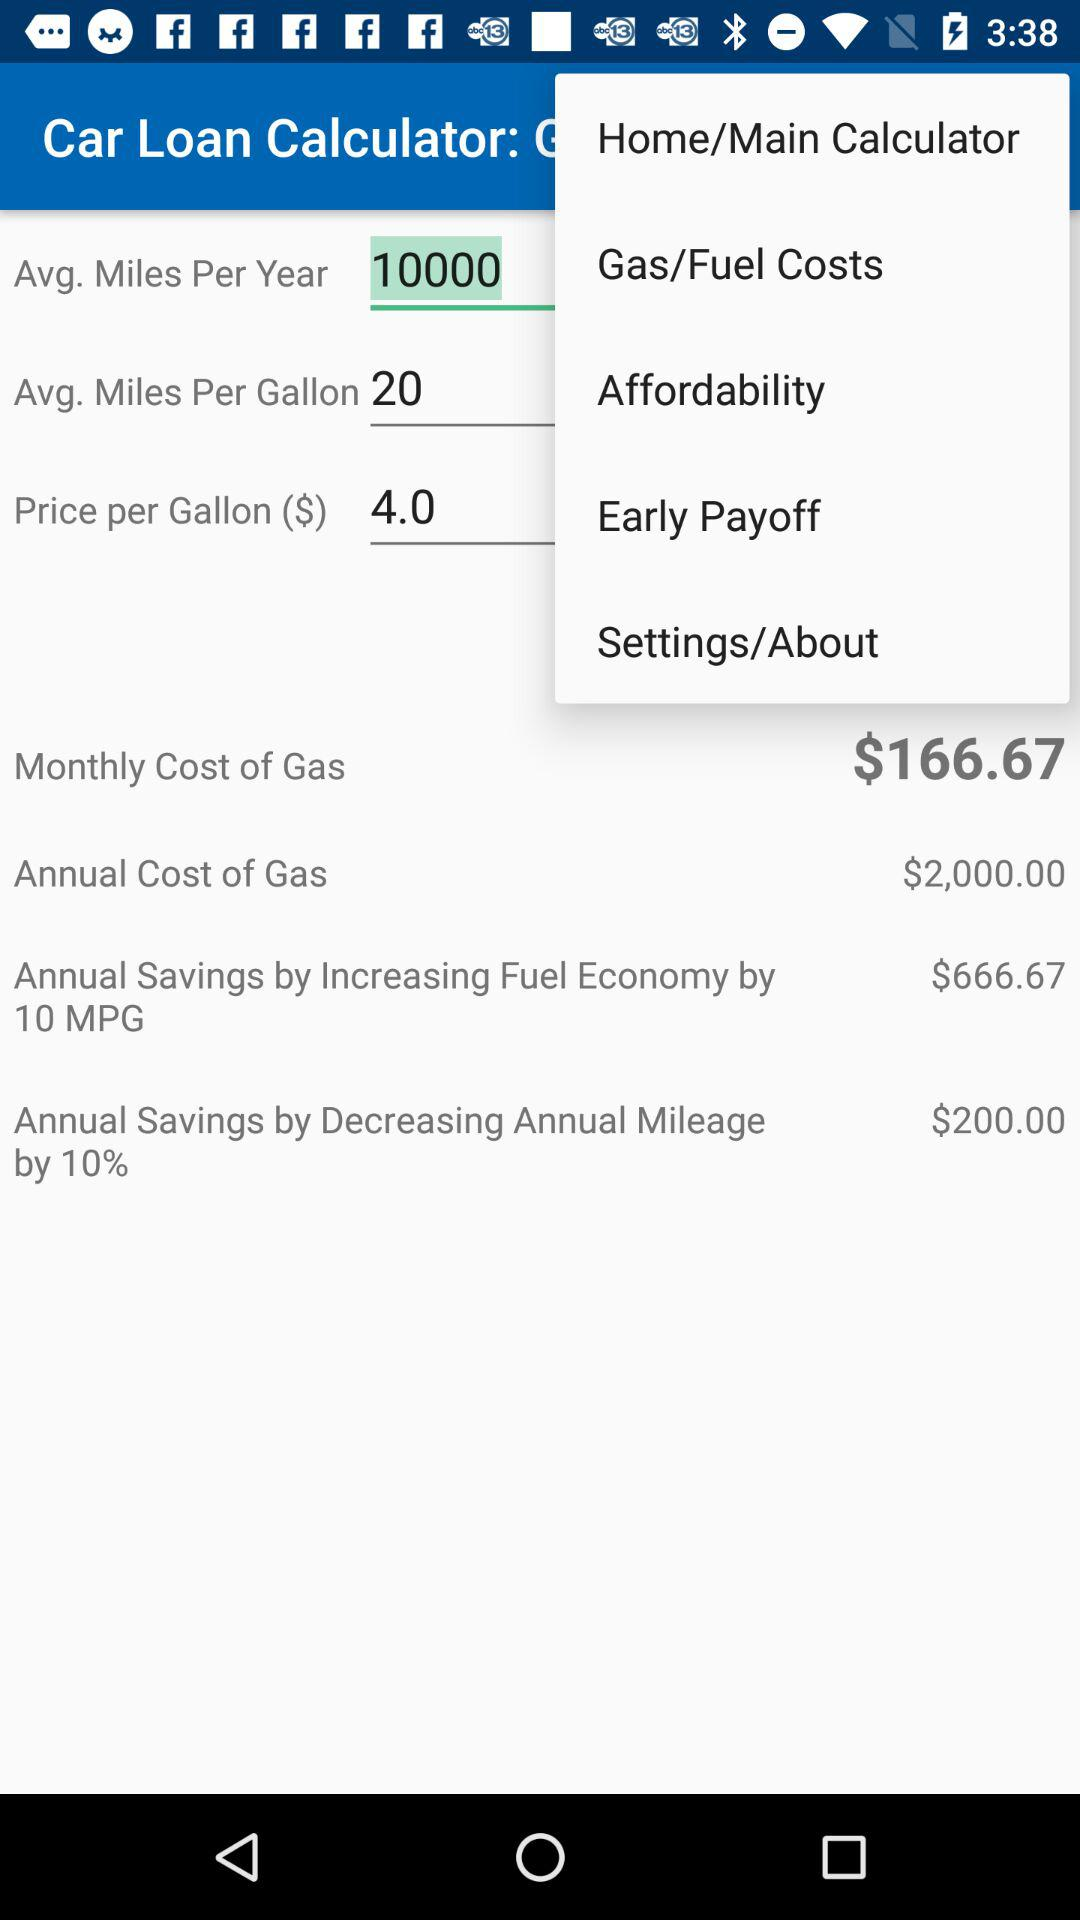How much money would I save per year by decreasing my annual mileage by 10%?
Answer the question using a single word or phrase. $200.00 